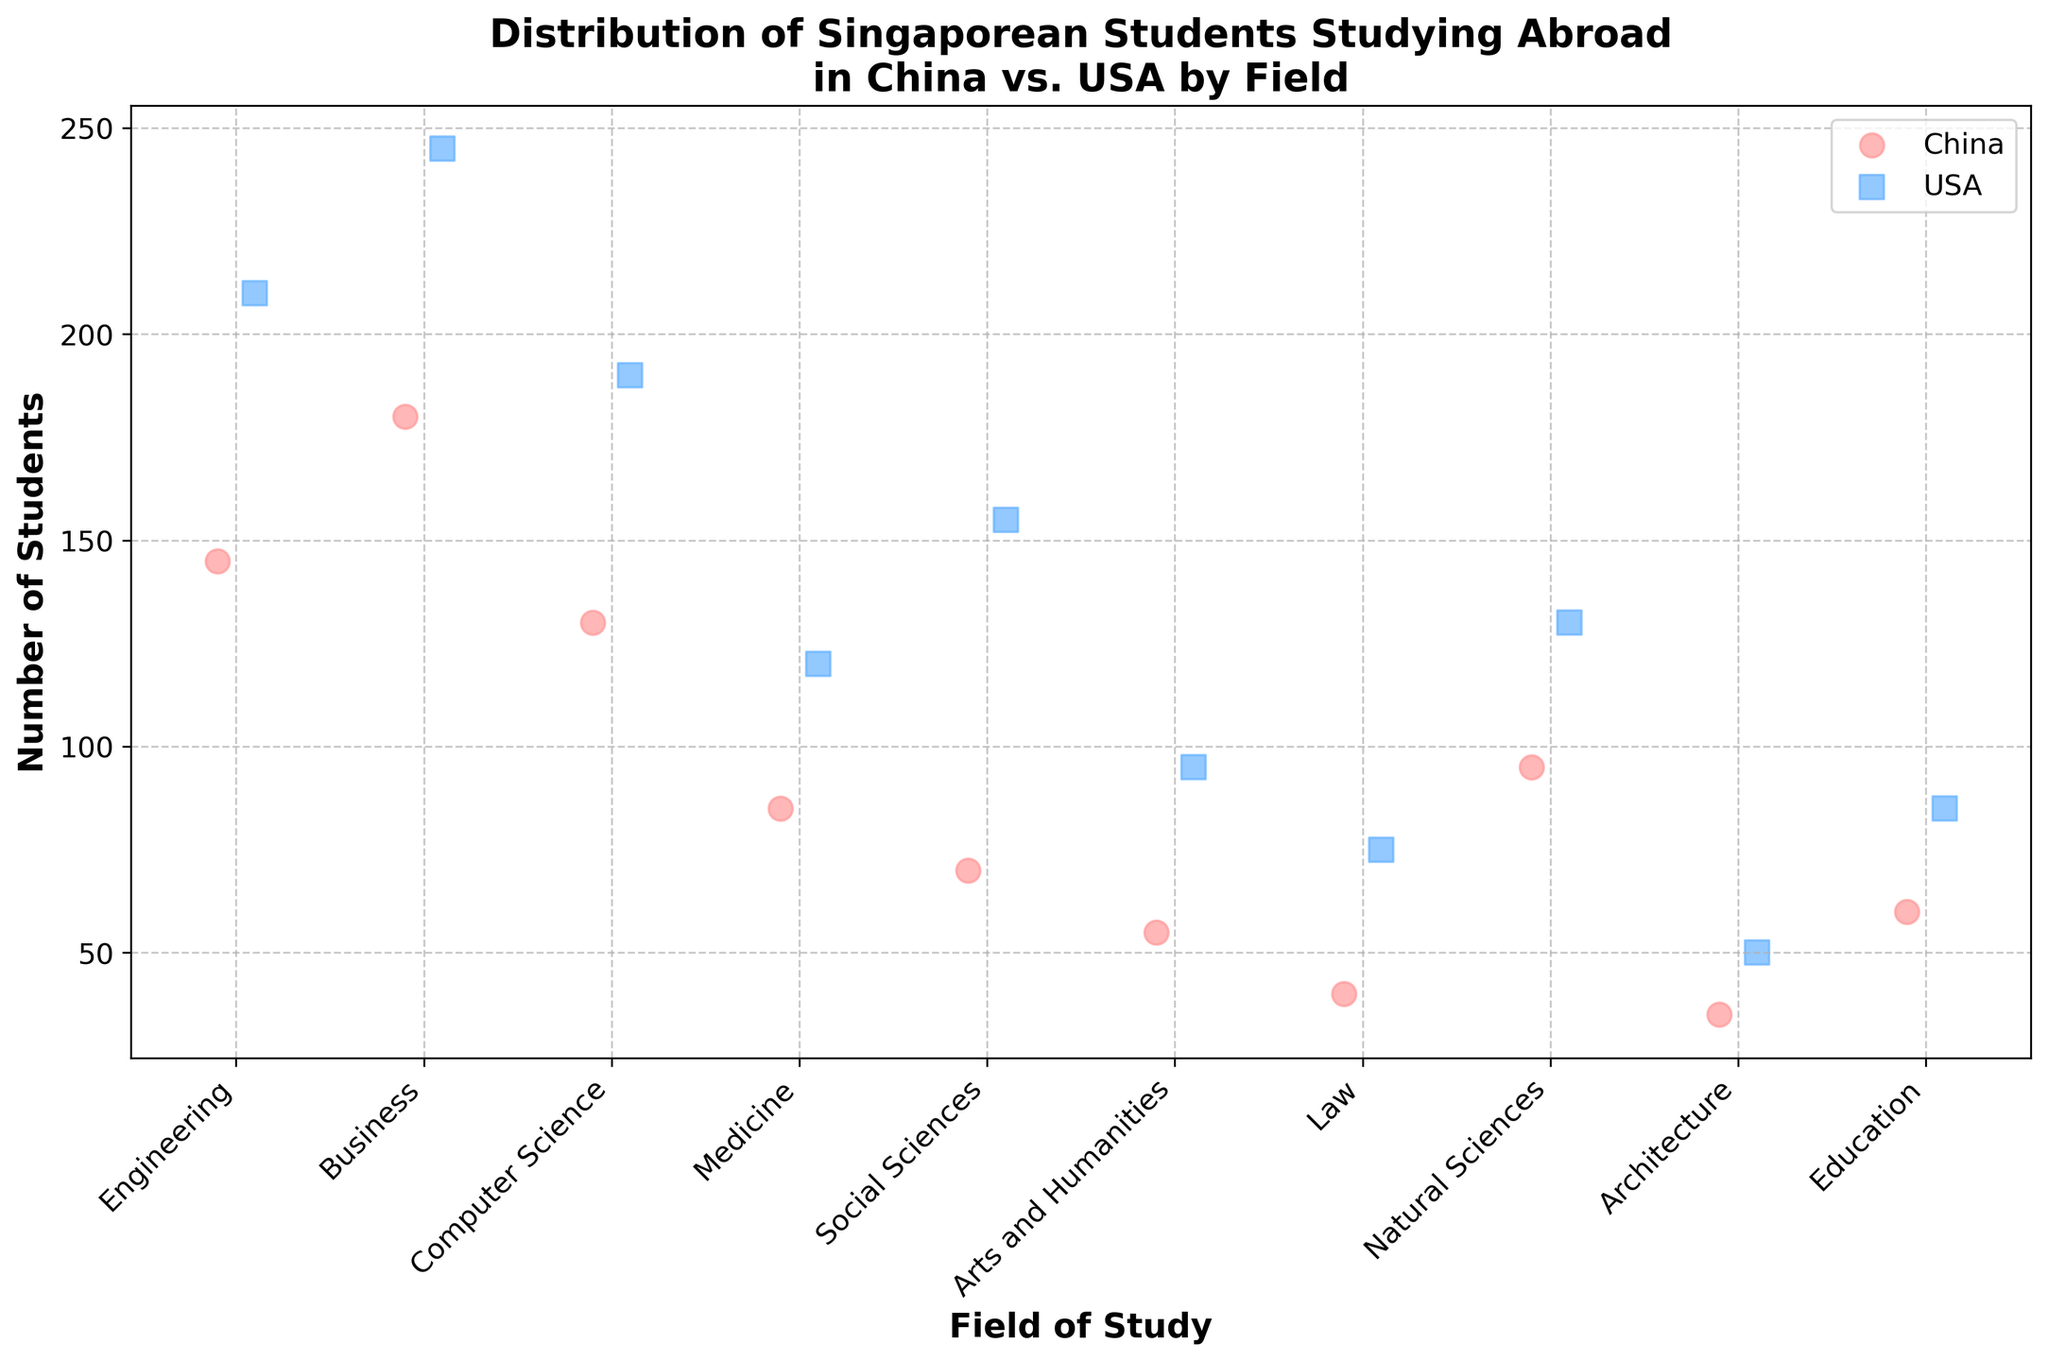How many fields of study are being compared in the plot? Count the number of unique fields of study along the x-axis.
Answer: 10 Which country has more students studying Engineering? Look at the data points on the Engineering category for both China and the USA, and compare their heights.
Answer: USA What is the approximate difference in the number of students studying Business between China and the USA? Find the data points for Business for both China and the USA, then subtract China's number from USA's number (245 - 180).
Answer: 65 In which field does China have the highest number of students? Identify the data points for all fields for China and find the highest one.
Answer: Business Is the number of students studying Natural Sciences in China greater than the number studying Social Sciences in China? Compare the y-values for Natural Sciences and Social Sciences data points for China.
Answer: Yes What is the total number of Singaporean students studying Medicine abroad? Add the number of students studying Medicine in China (85) and the USA (120).
Answer: 205 Which field shows a notable difference in the number of students studying in China vs. the USA, and what is that difference? Observe fields with large gaps between the respective data points, then calculate the differences, for instance, Social Sciences (155-70) = 85.
Answer: Social Sciences, 85 In which field does the USA have the lowest number of students? Identify the lowest data point for the USA across all fields.
Answer: Architecture Compare the number of students studying Computer Science in China to those studying Natural Sciences in the USA. Which is higher? Look at the data points for Computer Science in China and Natural Sciences in the USA, and compare their heights.
Answer: Natural Sciences in the USA What is the average number of students studying Arts and Humanities across both countries? Add the number of students studying Arts and Humanities in China (55) and the USA (95), then divide by 2 ((55+95)/2).
Answer: 75 